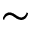<formula> <loc_0><loc_0><loc_500><loc_500>\sim</formula> 